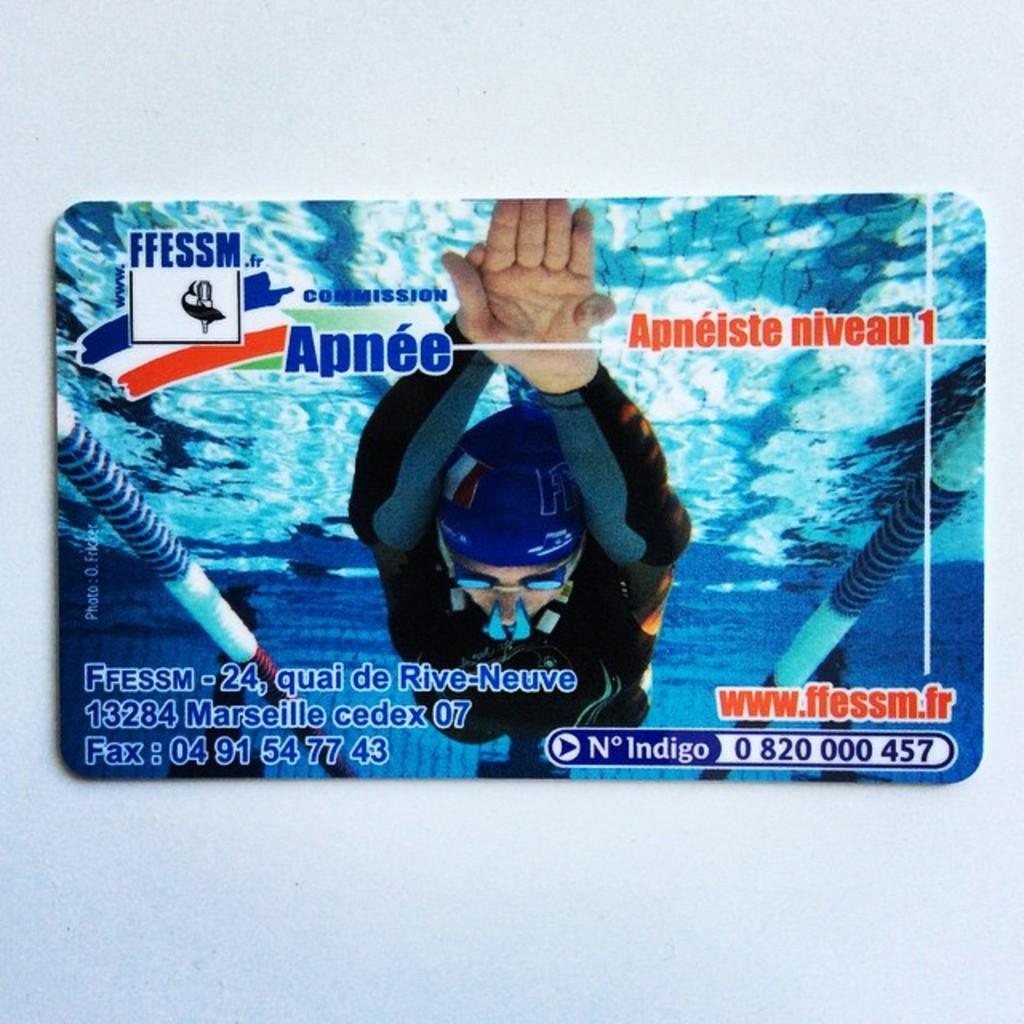Can you describe this image briefly? In this image there is a card. On the card we can see that there is a person in the swimming pool. At the bottom there is some text. In the background there is white color wall. 